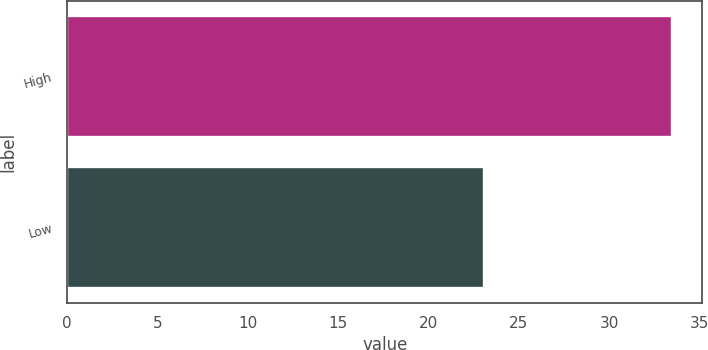Convert chart. <chart><loc_0><loc_0><loc_500><loc_500><bar_chart><fcel>High<fcel>Low<nl><fcel>33.5<fcel>23.06<nl></chart> 